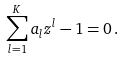Convert formula to latex. <formula><loc_0><loc_0><loc_500><loc_500>\sum _ { l = 1 } ^ { K } a _ { l } z ^ { l } - 1 = 0 \, .</formula> 